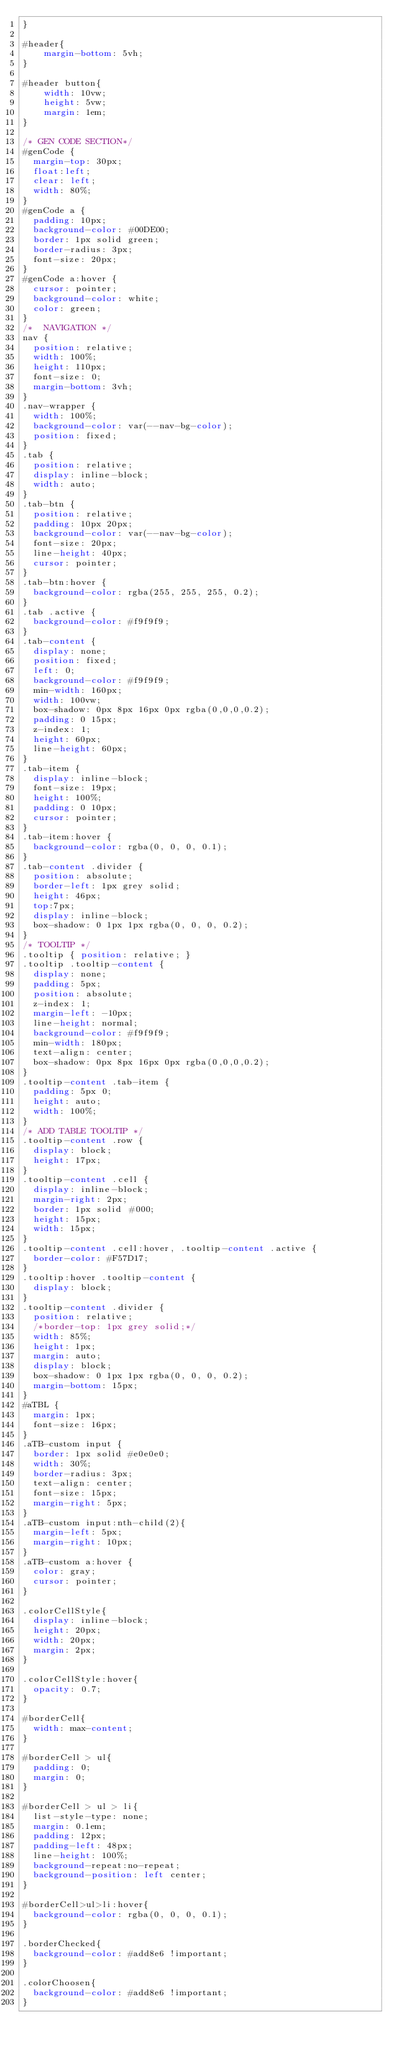<code> <loc_0><loc_0><loc_500><loc_500><_CSS_>}

#header{
    margin-bottom: 5vh;
}

#header button{
    width: 10vw;
    height: 5vw;
    margin: 1em;
}

/* GEN CODE SECTION*/
#genCode {
  margin-top: 30px;
  float:left; 
  clear: left;
  width: 80%;
}
#genCode a {
  padding: 10px;
  background-color: #00DE00;
  border: 1px solid green;
  border-radius: 3px;
  font-size: 20px;
}
#genCode a:hover {
  cursor: pointer;
  background-color: white;
  color: green;
}
/*  NAVIGATION */
nav {
  position: relative;
  width: 100%;
  height: 110px;
  font-size: 0;
  margin-bottom: 3vh;
}
.nav-wrapper {
  width: 100%;
  background-color: var(--nav-bg-color);
  position: fixed;
}
.tab {
  position: relative;
  display: inline-block;
  width: auto;
}
.tab-btn {
  position: relative;
  padding: 10px 20px;
  background-color: var(--nav-bg-color);
  font-size: 20px;
  line-height: 40px;
  cursor: pointer;
}
.tab-btn:hover {
  background-color: rgba(255, 255, 255, 0.2);
}
.tab .active {
  background-color: #f9f9f9;
}
.tab-content {
  display: none;
  position: fixed;
  left: 0;
  background-color: #f9f9f9;
  min-width: 160px;
  width: 100vw;
  box-shadow: 0px 8px 16px 0px rgba(0,0,0,0.2);
  padding: 0 15px;
  z-index: 1;
  height: 60px;
  line-height: 60px;
}
.tab-item {
  display: inline-block;
  font-size: 19px;
  height: 100%;
  padding: 0 10px;
  cursor: pointer;
}
.tab-item:hover {
  background-color: rgba(0, 0, 0, 0.1);
}
.tab-content .divider {
  position: absolute;
  border-left: 1px grey solid;
  height: 46px;
  top:7px;
  display: inline-block;
  box-shadow: 0 1px 1px rgba(0, 0, 0, 0.2);
}
/* TOOLTIP */
.tooltip { position: relative; }
.tooltip .tooltip-content {
  display: none;
  padding: 5px;
  position: absolute;
  z-index: 1;
  margin-left: -10px;
  line-height: normal;
  background-color: #f9f9f9;
  min-width: 180px;
  text-align: center;
  box-shadow: 0px 8px 16px 0px rgba(0,0,0,0.2);
}
.tooltip-content .tab-item {
  padding: 5px 0;
  height: auto;
  width: 100%;
}
/* ADD TABLE TOOLTIP */
.tooltip-content .row {
  display: block;
  height: 17px;
}
.tooltip-content .cell {
  display: inline-block;
  margin-right: 2px;
  border: 1px solid #000;
  height: 15px;
  width: 15px;
}
.tooltip-content .cell:hover, .tooltip-content .active {
  border-color: #F57D17;
}
.tooltip:hover .tooltip-content {
  display: block;
}
.tooltip-content .divider {
  position: relative;
  /*border-top: 1px grey solid;*/
  width: 85%;
  height: 1px;
  margin: auto;
  display: block;
  box-shadow: 0 1px 1px rgba(0, 0, 0, 0.2);
  margin-bottom: 15px;
}
#aTBL {
  margin: 1px;
  font-size: 16px;
}
.aTB-custom input {
  border: 1px solid #e0e0e0;
  width: 30%;
  border-radius: 3px;
  text-align: center;
  font-size: 15px;
  margin-right: 5px;
}
.aTB-custom input:nth-child(2){
  margin-left: 5px;
  margin-right: 10px;
}
.aTB-custom a:hover {
  color: gray;
  cursor: pointer;
}

.colorCellStyle{
  display: inline-block;
  height: 20px;
  width: 20px;
  margin: 2px;
}

.colorCellStyle:hover{
  opacity: 0.7;
}

#borderCell{
  width: max-content;
}

#borderCell > ul{
  padding: 0;
  margin: 0;
}

#borderCell > ul > li{
  list-style-type: none;
  margin: 0.1em;
  padding: 12px;
  padding-left: 48px;
  line-height: 100%;
  background-repeat:no-repeat;
  background-position: left center;
}

#borderCell>ul>li:hover{
  background-color: rgba(0, 0, 0, 0.1);
}

.borderChecked{
  background-color: #add8e6 !important;
}

.colorChoosen{
  background-color: #add8e6 !important;
}
</code> 